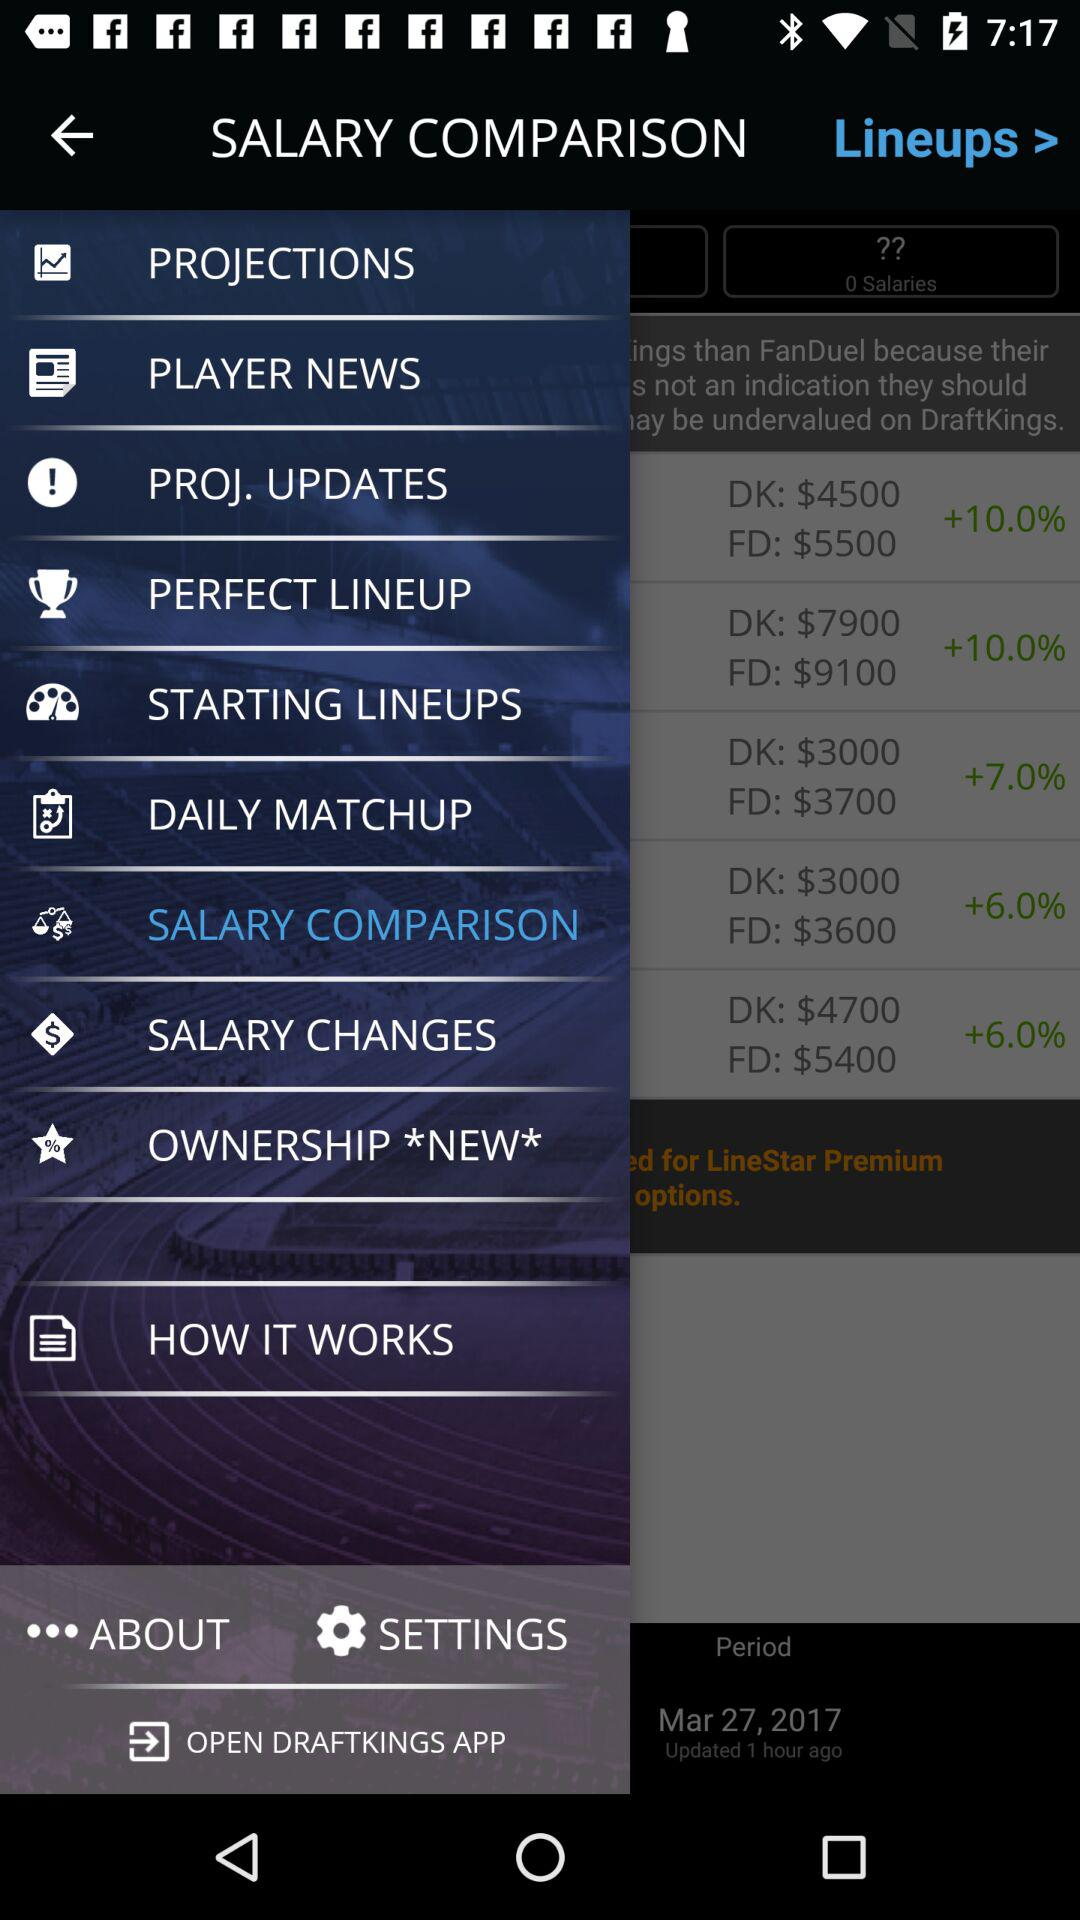How much more does the highest priced player on DraftKings cost than the highest priced player on FanDuel?
Answer the question using a single word or phrase. 1200 